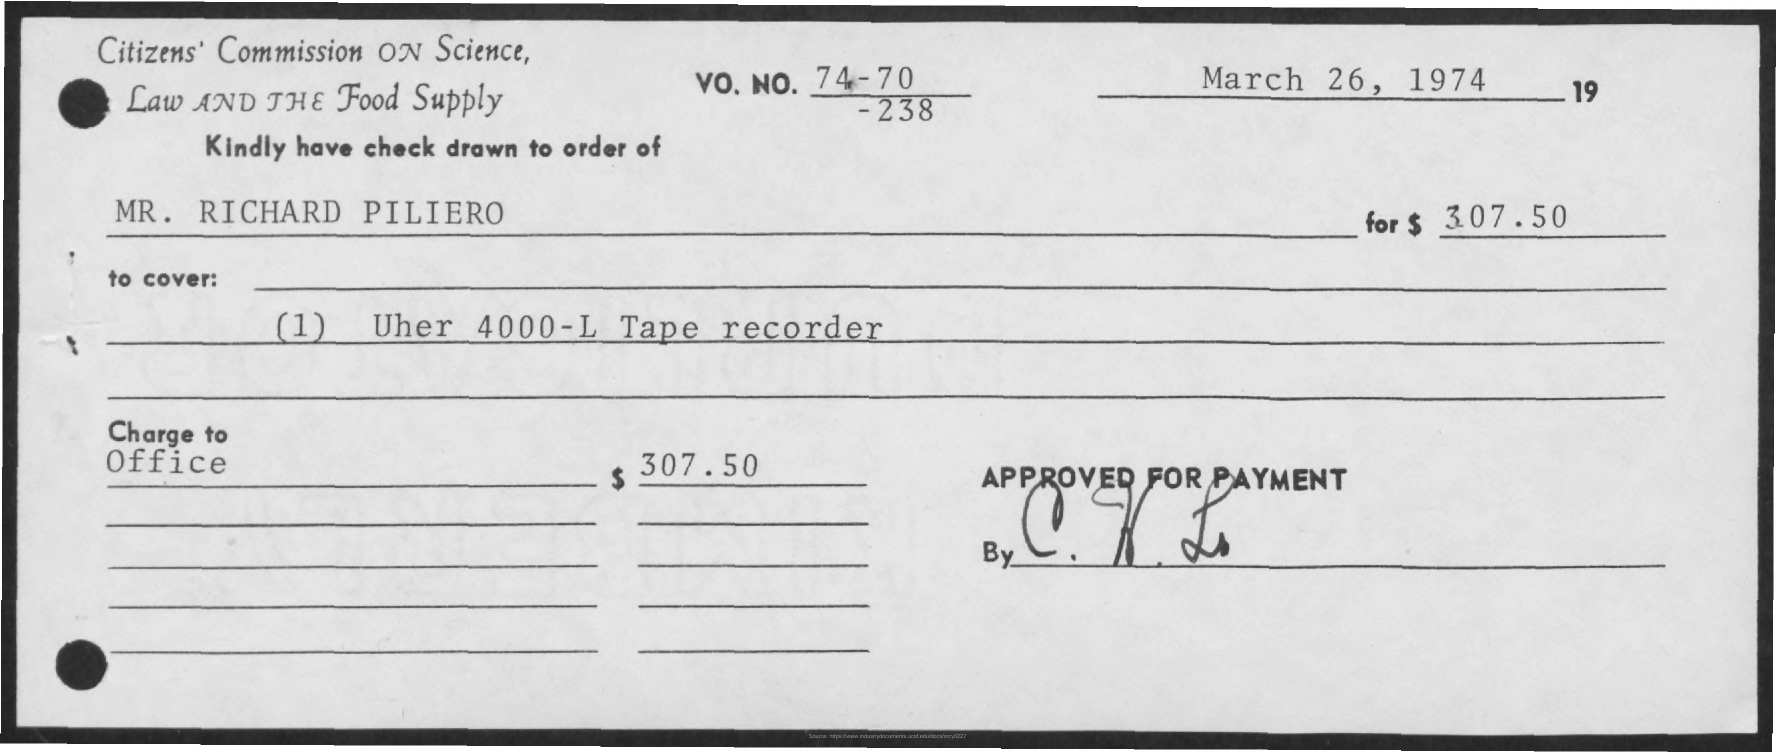Point out several critical features in this image. The Uher 4000-L tape recorder is mentioned in the document to be covered. The amount mentioned is $307.50. MR. Richard Piliero's name is mentioned. The date mentioned is March 26, 1974. 